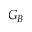<formula> <loc_0><loc_0><loc_500><loc_500>G _ { B }</formula> 